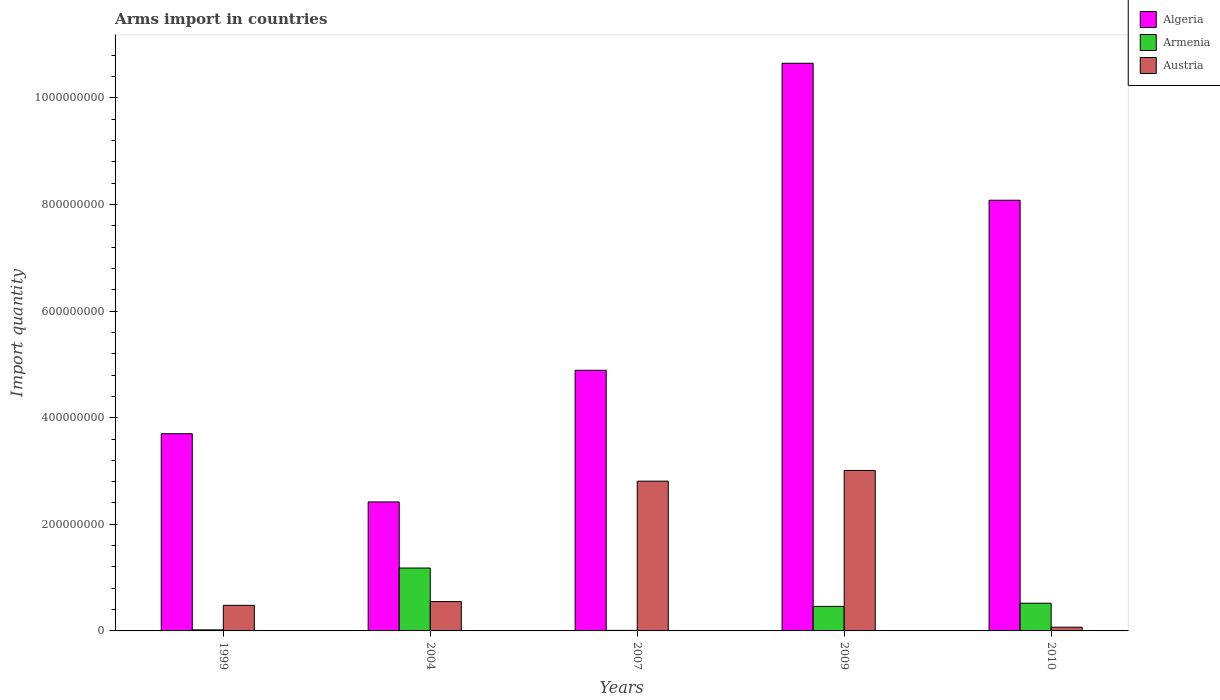How many groups of bars are there?
Ensure brevity in your answer.  5. What is the total arms import in Austria in 2010?
Offer a terse response. 7.00e+06. Across all years, what is the maximum total arms import in Algeria?
Keep it short and to the point. 1.06e+09. Across all years, what is the minimum total arms import in Austria?
Ensure brevity in your answer.  7.00e+06. What is the total total arms import in Austria in the graph?
Make the answer very short. 6.92e+08. What is the difference between the total arms import in Austria in 2004 and that in 2009?
Offer a terse response. -2.46e+08. What is the difference between the total arms import in Austria in 2007 and the total arms import in Algeria in 2009?
Your response must be concise. -7.84e+08. What is the average total arms import in Armenia per year?
Your response must be concise. 4.38e+07. In the year 2007, what is the difference between the total arms import in Armenia and total arms import in Algeria?
Make the answer very short. -4.88e+08. What is the ratio of the total arms import in Austria in 1999 to that in 2007?
Your response must be concise. 0.17. Is the difference between the total arms import in Armenia in 2004 and 2007 greater than the difference between the total arms import in Algeria in 2004 and 2007?
Your response must be concise. Yes. What is the difference between the highest and the second highest total arms import in Algeria?
Your response must be concise. 2.57e+08. What is the difference between the highest and the lowest total arms import in Austria?
Your answer should be very brief. 2.94e+08. In how many years, is the total arms import in Algeria greater than the average total arms import in Algeria taken over all years?
Your answer should be very brief. 2. Is the sum of the total arms import in Algeria in 1999 and 2004 greater than the maximum total arms import in Austria across all years?
Make the answer very short. Yes. What does the 1st bar from the left in 2004 represents?
Offer a terse response. Algeria. Is it the case that in every year, the sum of the total arms import in Algeria and total arms import in Austria is greater than the total arms import in Armenia?
Offer a very short reply. Yes. Are all the bars in the graph horizontal?
Your answer should be compact. No. How many years are there in the graph?
Make the answer very short. 5. What is the difference between two consecutive major ticks on the Y-axis?
Your answer should be very brief. 2.00e+08. Does the graph contain any zero values?
Provide a short and direct response. No. Does the graph contain grids?
Keep it short and to the point. No. How many legend labels are there?
Keep it short and to the point. 3. What is the title of the graph?
Give a very brief answer. Arms import in countries. What is the label or title of the X-axis?
Give a very brief answer. Years. What is the label or title of the Y-axis?
Offer a terse response. Import quantity. What is the Import quantity in Algeria in 1999?
Your answer should be compact. 3.70e+08. What is the Import quantity of Austria in 1999?
Provide a short and direct response. 4.80e+07. What is the Import quantity in Algeria in 2004?
Your response must be concise. 2.42e+08. What is the Import quantity of Armenia in 2004?
Provide a short and direct response. 1.18e+08. What is the Import quantity in Austria in 2004?
Offer a very short reply. 5.50e+07. What is the Import quantity of Algeria in 2007?
Keep it short and to the point. 4.89e+08. What is the Import quantity in Armenia in 2007?
Provide a short and direct response. 1.00e+06. What is the Import quantity of Austria in 2007?
Your response must be concise. 2.81e+08. What is the Import quantity of Algeria in 2009?
Ensure brevity in your answer.  1.06e+09. What is the Import quantity in Armenia in 2009?
Make the answer very short. 4.60e+07. What is the Import quantity of Austria in 2009?
Ensure brevity in your answer.  3.01e+08. What is the Import quantity of Algeria in 2010?
Give a very brief answer. 8.08e+08. What is the Import quantity in Armenia in 2010?
Your answer should be very brief. 5.20e+07. What is the Import quantity of Austria in 2010?
Provide a short and direct response. 7.00e+06. Across all years, what is the maximum Import quantity of Algeria?
Ensure brevity in your answer.  1.06e+09. Across all years, what is the maximum Import quantity of Armenia?
Ensure brevity in your answer.  1.18e+08. Across all years, what is the maximum Import quantity of Austria?
Offer a terse response. 3.01e+08. Across all years, what is the minimum Import quantity of Algeria?
Provide a succinct answer. 2.42e+08. Across all years, what is the minimum Import quantity of Armenia?
Offer a terse response. 1.00e+06. Across all years, what is the minimum Import quantity of Austria?
Offer a terse response. 7.00e+06. What is the total Import quantity in Algeria in the graph?
Your answer should be very brief. 2.97e+09. What is the total Import quantity in Armenia in the graph?
Your response must be concise. 2.19e+08. What is the total Import quantity in Austria in the graph?
Give a very brief answer. 6.92e+08. What is the difference between the Import quantity in Algeria in 1999 and that in 2004?
Provide a short and direct response. 1.28e+08. What is the difference between the Import quantity of Armenia in 1999 and that in 2004?
Your answer should be compact. -1.16e+08. What is the difference between the Import quantity of Austria in 1999 and that in 2004?
Ensure brevity in your answer.  -7.00e+06. What is the difference between the Import quantity of Algeria in 1999 and that in 2007?
Keep it short and to the point. -1.19e+08. What is the difference between the Import quantity in Austria in 1999 and that in 2007?
Your answer should be very brief. -2.33e+08. What is the difference between the Import quantity in Algeria in 1999 and that in 2009?
Offer a very short reply. -6.95e+08. What is the difference between the Import quantity in Armenia in 1999 and that in 2009?
Your response must be concise. -4.40e+07. What is the difference between the Import quantity of Austria in 1999 and that in 2009?
Your response must be concise. -2.53e+08. What is the difference between the Import quantity in Algeria in 1999 and that in 2010?
Provide a short and direct response. -4.38e+08. What is the difference between the Import quantity in Armenia in 1999 and that in 2010?
Your answer should be very brief. -5.00e+07. What is the difference between the Import quantity in Austria in 1999 and that in 2010?
Your answer should be compact. 4.10e+07. What is the difference between the Import quantity in Algeria in 2004 and that in 2007?
Provide a short and direct response. -2.47e+08. What is the difference between the Import quantity of Armenia in 2004 and that in 2007?
Offer a very short reply. 1.17e+08. What is the difference between the Import quantity in Austria in 2004 and that in 2007?
Make the answer very short. -2.26e+08. What is the difference between the Import quantity of Algeria in 2004 and that in 2009?
Provide a short and direct response. -8.23e+08. What is the difference between the Import quantity of Armenia in 2004 and that in 2009?
Give a very brief answer. 7.20e+07. What is the difference between the Import quantity in Austria in 2004 and that in 2009?
Your answer should be very brief. -2.46e+08. What is the difference between the Import quantity of Algeria in 2004 and that in 2010?
Your answer should be very brief. -5.66e+08. What is the difference between the Import quantity in Armenia in 2004 and that in 2010?
Provide a succinct answer. 6.60e+07. What is the difference between the Import quantity in Austria in 2004 and that in 2010?
Your answer should be very brief. 4.80e+07. What is the difference between the Import quantity of Algeria in 2007 and that in 2009?
Offer a terse response. -5.76e+08. What is the difference between the Import quantity of Armenia in 2007 and that in 2009?
Provide a succinct answer. -4.50e+07. What is the difference between the Import quantity of Austria in 2007 and that in 2009?
Your answer should be compact. -2.00e+07. What is the difference between the Import quantity of Algeria in 2007 and that in 2010?
Ensure brevity in your answer.  -3.19e+08. What is the difference between the Import quantity in Armenia in 2007 and that in 2010?
Your answer should be compact. -5.10e+07. What is the difference between the Import quantity of Austria in 2007 and that in 2010?
Provide a short and direct response. 2.74e+08. What is the difference between the Import quantity in Algeria in 2009 and that in 2010?
Make the answer very short. 2.57e+08. What is the difference between the Import quantity of Armenia in 2009 and that in 2010?
Give a very brief answer. -6.00e+06. What is the difference between the Import quantity in Austria in 2009 and that in 2010?
Offer a very short reply. 2.94e+08. What is the difference between the Import quantity of Algeria in 1999 and the Import quantity of Armenia in 2004?
Offer a very short reply. 2.52e+08. What is the difference between the Import quantity of Algeria in 1999 and the Import quantity of Austria in 2004?
Provide a succinct answer. 3.15e+08. What is the difference between the Import quantity in Armenia in 1999 and the Import quantity in Austria in 2004?
Your answer should be compact. -5.30e+07. What is the difference between the Import quantity in Algeria in 1999 and the Import quantity in Armenia in 2007?
Your answer should be compact. 3.69e+08. What is the difference between the Import quantity of Algeria in 1999 and the Import quantity of Austria in 2007?
Your answer should be compact. 8.90e+07. What is the difference between the Import quantity of Armenia in 1999 and the Import quantity of Austria in 2007?
Your answer should be compact. -2.79e+08. What is the difference between the Import quantity in Algeria in 1999 and the Import quantity in Armenia in 2009?
Make the answer very short. 3.24e+08. What is the difference between the Import quantity in Algeria in 1999 and the Import quantity in Austria in 2009?
Keep it short and to the point. 6.90e+07. What is the difference between the Import quantity in Armenia in 1999 and the Import quantity in Austria in 2009?
Provide a succinct answer. -2.99e+08. What is the difference between the Import quantity of Algeria in 1999 and the Import quantity of Armenia in 2010?
Offer a terse response. 3.18e+08. What is the difference between the Import quantity of Algeria in 1999 and the Import quantity of Austria in 2010?
Make the answer very short. 3.63e+08. What is the difference between the Import quantity of Armenia in 1999 and the Import quantity of Austria in 2010?
Your answer should be compact. -5.00e+06. What is the difference between the Import quantity of Algeria in 2004 and the Import quantity of Armenia in 2007?
Offer a very short reply. 2.41e+08. What is the difference between the Import quantity of Algeria in 2004 and the Import quantity of Austria in 2007?
Provide a succinct answer. -3.90e+07. What is the difference between the Import quantity in Armenia in 2004 and the Import quantity in Austria in 2007?
Make the answer very short. -1.63e+08. What is the difference between the Import quantity in Algeria in 2004 and the Import quantity in Armenia in 2009?
Provide a succinct answer. 1.96e+08. What is the difference between the Import quantity in Algeria in 2004 and the Import quantity in Austria in 2009?
Your answer should be very brief. -5.90e+07. What is the difference between the Import quantity of Armenia in 2004 and the Import quantity of Austria in 2009?
Give a very brief answer. -1.83e+08. What is the difference between the Import quantity in Algeria in 2004 and the Import quantity in Armenia in 2010?
Provide a short and direct response. 1.90e+08. What is the difference between the Import quantity of Algeria in 2004 and the Import quantity of Austria in 2010?
Ensure brevity in your answer.  2.35e+08. What is the difference between the Import quantity of Armenia in 2004 and the Import quantity of Austria in 2010?
Your answer should be compact. 1.11e+08. What is the difference between the Import quantity in Algeria in 2007 and the Import quantity in Armenia in 2009?
Keep it short and to the point. 4.43e+08. What is the difference between the Import quantity in Algeria in 2007 and the Import quantity in Austria in 2009?
Offer a terse response. 1.88e+08. What is the difference between the Import quantity of Armenia in 2007 and the Import quantity of Austria in 2009?
Offer a very short reply. -3.00e+08. What is the difference between the Import quantity of Algeria in 2007 and the Import quantity of Armenia in 2010?
Your response must be concise. 4.37e+08. What is the difference between the Import quantity of Algeria in 2007 and the Import quantity of Austria in 2010?
Ensure brevity in your answer.  4.82e+08. What is the difference between the Import quantity in Armenia in 2007 and the Import quantity in Austria in 2010?
Your answer should be very brief. -6.00e+06. What is the difference between the Import quantity in Algeria in 2009 and the Import quantity in Armenia in 2010?
Provide a succinct answer. 1.01e+09. What is the difference between the Import quantity of Algeria in 2009 and the Import quantity of Austria in 2010?
Your answer should be very brief. 1.06e+09. What is the difference between the Import quantity in Armenia in 2009 and the Import quantity in Austria in 2010?
Provide a succinct answer. 3.90e+07. What is the average Import quantity of Algeria per year?
Offer a very short reply. 5.95e+08. What is the average Import quantity in Armenia per year?
Provide a short and direct response. 4.38e+07. What is the average Import quantity of Austria per year?
Offer a terse response. 1.38e+08. In the year 1999, what is the difference between the Import quantity in Algeria and Import quantity in Armenia?
Provide a succinct answer. 3.68e+08. In the year 1999, what is the difference between the Import quantity in Algeria and Import quantity in Austria?
Your answer should be very brief. 3.22e+08. In the year 1999, what is the difference between the Import quantity of Armenia and Import quantity of Austria?
Provide a short and direct response. -4.60e+07. In the year 2004, what is the difference between the Import quantity of Algeria and Import quantity of Armenia?
Your response must be concise. 1.24e+08. In the year 2004, what is the difference between the Import quantity of Algeria and Import quantity of Austria?
Provide a short and direct response. 1.87e+08. In the year 2004, what is the difference between the Import quantity of Armenia and Import quantity of Austria?
Your answer should be very brief. 6.30e+07. In the year 2007, what is the difference between the Import quantity of Algeria and Import quantity of Armenia?
Your response must be concise. 4.88e+08. In the year 2007, what is the difference between the Import quantity of Algeria and Import quantity of Austria?
Provide a short and direct response. 2.08e+08. In the year 2007, what is the difference between the Import quantity in Armenia and Import quantity in Austria?
Give a very brief answer. -2.80e+08. In the year 2009, what is the difference between the Import quantity in Algeria and Import quantity in Armenia?
Your answer should be very brief. 1.02e+09. In the year 2009, what is the difference between the Import quantity in Algeria and Import quantity in Austria?
Keep it short and to the point. 7.64e+08. In the year 2009, what is the difference between the Import quantity in Armenia and Import quantity in Austria?
Your answer should be compact. -2.55e+08. In the year 2010, what is the difference between the Import quantity of Algeria and Import quantity of Armenia?
Offer a terse response. 7.56e+08. In the year 2010, what is the difference between the Import quantity in Algeria and Import quantity in Austria?
Keep it short and to the point. 8.01e+08. In the year 2010, what is the difference between the Import quantity of Armenia and Import quantity of Austria?
Provide a succinct answer. 4.50e+07. What is the ratio of the Import quantity of Algeria in 1999 to that in 2004?
Your answer should be compact. 1.53. What is the ratio of the Import quantity of Armenia in 1999 to that in 2004?
Your answer should be very brief. 0.02. What is the ratio of the Import quantity of Austria in 1999 to that in 2004?
Keep it short and to the point. 0.87. What is the ratio of the Import quantity in Algeria in 1999 to that in 2007?
Your answer should be compact. 0.76. What is the ratio of the Import quantity in Armenia in 1999 to that in 2007?
Keep it short and to the point. 2. What is the ratio of the Import quantity of Austria in 1999 to that in 2007?
Your answer should be compact. 0.17. What is the ratio of the Import quantity in Algeria in 1999 to that in 2009?
Keep it short and to the point. 0.35. What is the ratio of the Import quantity of Armenia in 1999 to that in 2009?
Ensure brevity in your answer.  0.04. What is the ratio of the Import quantity of Austria in 1999 to that in 2009?
Offer a very short reply. 0.16. What is the ratio of the Import quantity in Algeria in 1999 to that in 2010?
Offer a very short reply. 0.46. What is the ratio of the Import quantity in Armenia in 1999 to that in 2010?
Your answer should be very brief. 0.04. What is the ratio of the Import quantity of Austria in 1999 to that in 2010?
Provide a succinct answer. 6.86. What is the ratio of the Import quantity in Algeria in 2004 to that in 2007?
Offer a very short reply. 0.49. What is the ratio of the Import quantity of Armenia in 2004 to that in 2007?
Your answer should be compact. 118. What is the ratio of the Import quantity in Austria in 2004 to that in 2007?
Ensure brevity in your answer.  0.2. What is the ratio of the Import quantity in Algeria in 2004 to that in 2009?
Provide a succinct answer. 0.23. What is the ratio of the Import quantity in Armenia in 2004 to that in 2009?
Keep it short and to the point. 2.57. What is the ratio of the Import quantity in Austria in 2004 to that in 2009?
Your response must be concise. 0.18. What is the ratio of the Import quantity in Algeria in 2004 to that in 2010?
Make the answer very short. 0.3. What is the ratio of the Import quantity of Armenia in 2004 to that in 2010?
Offer a very short reply. 2.27. What is the ratio of the Import quantity of Austria in 2004 to that in 2010?
Give a very brief answer. 7.86. What is the ratio of the Import quantity in Algeria in 2007 to that in 2009?
Your response must be concise. 0.46. What is the ratio of the Import quantity of Armenia in 2007 to that in 2009?
Your response must be concise. 0.02. What is the ratio of the Import quantity of Austria in 2007 to that in 2009?
Provide a succinct answer. 0.93. What is the ratio of the Import quantity of Algeria in 2007 to that in 2010?
Ensure brevity in your answer.  0.61. What is the ratio of the Import quantity of Armenia in 2007 to that in 2010?
Your answer should be compact. 0.02. What is the ratio of the Import quantity in Austria in 2007 to that in 2010?
Offer a very short reply. 40.14. What is the ratio of the Import quantity of Algeria in 2009 to that in 2010?
Offer a very short reply. 1.32. What is the ratio of the Import quantity in Armenia in 2009 to that in 2010?
Ensure brevity in your answer.  0.88. What is the difference between the highest and the second highest Import quantity of Algeria?
Your answer should be very brief. 2.57e+08. What is the difference between the highest and the second highest Import quantity of Armenia?
Your answer should be very brief. 6.60e+07. What is the difference between the highest and the second highest Import quantity in Austria?
Ensure brevity in your answer.  2.00e+07. What is the difference between the highest and the lowest Import quantity in Algeria?
Your answer should be compact. 8.23e+08. What is the difference between the highest and the lowest Import quantity of Armenia?
Give a very brief answer. 1.17e+08. What is the difference between the highest and the lowest Import quantity of Austria?
Provide a short and direct response. 2.94e+08. 